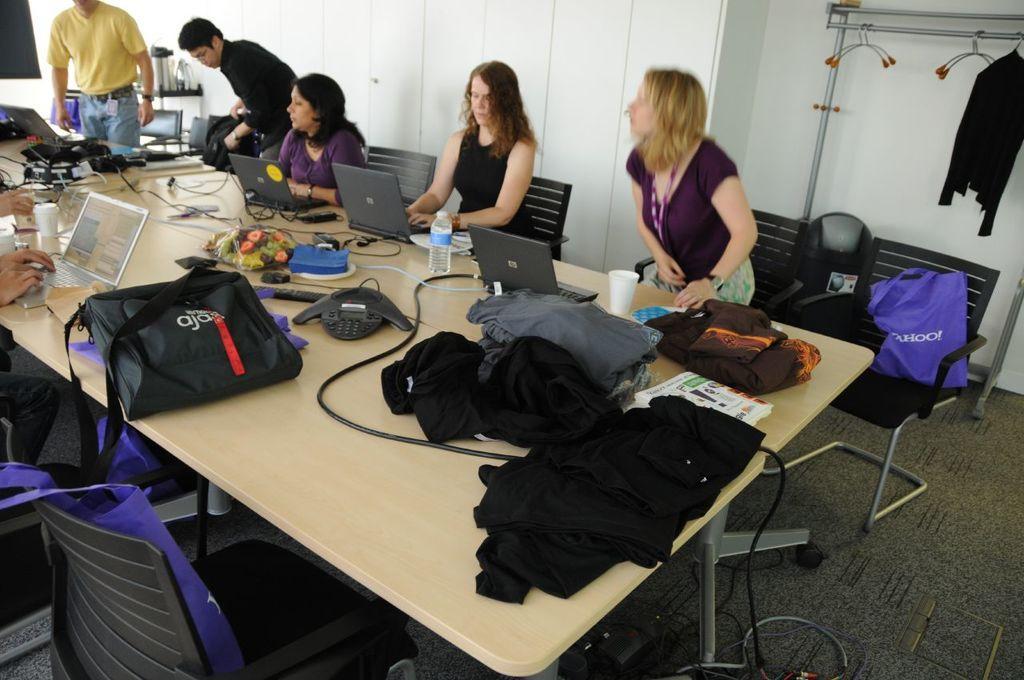Can you describe this image briefly? In this image there are three women sitting on chair. Two persons at the left top corner are standing. Person at the left side is sitting. There are two chairs at the left side of the image. There is a table on which bag, laptop, bottle are kept on it. There is a kettle on a table. At the right side a shirt is hanged to the hanger. 